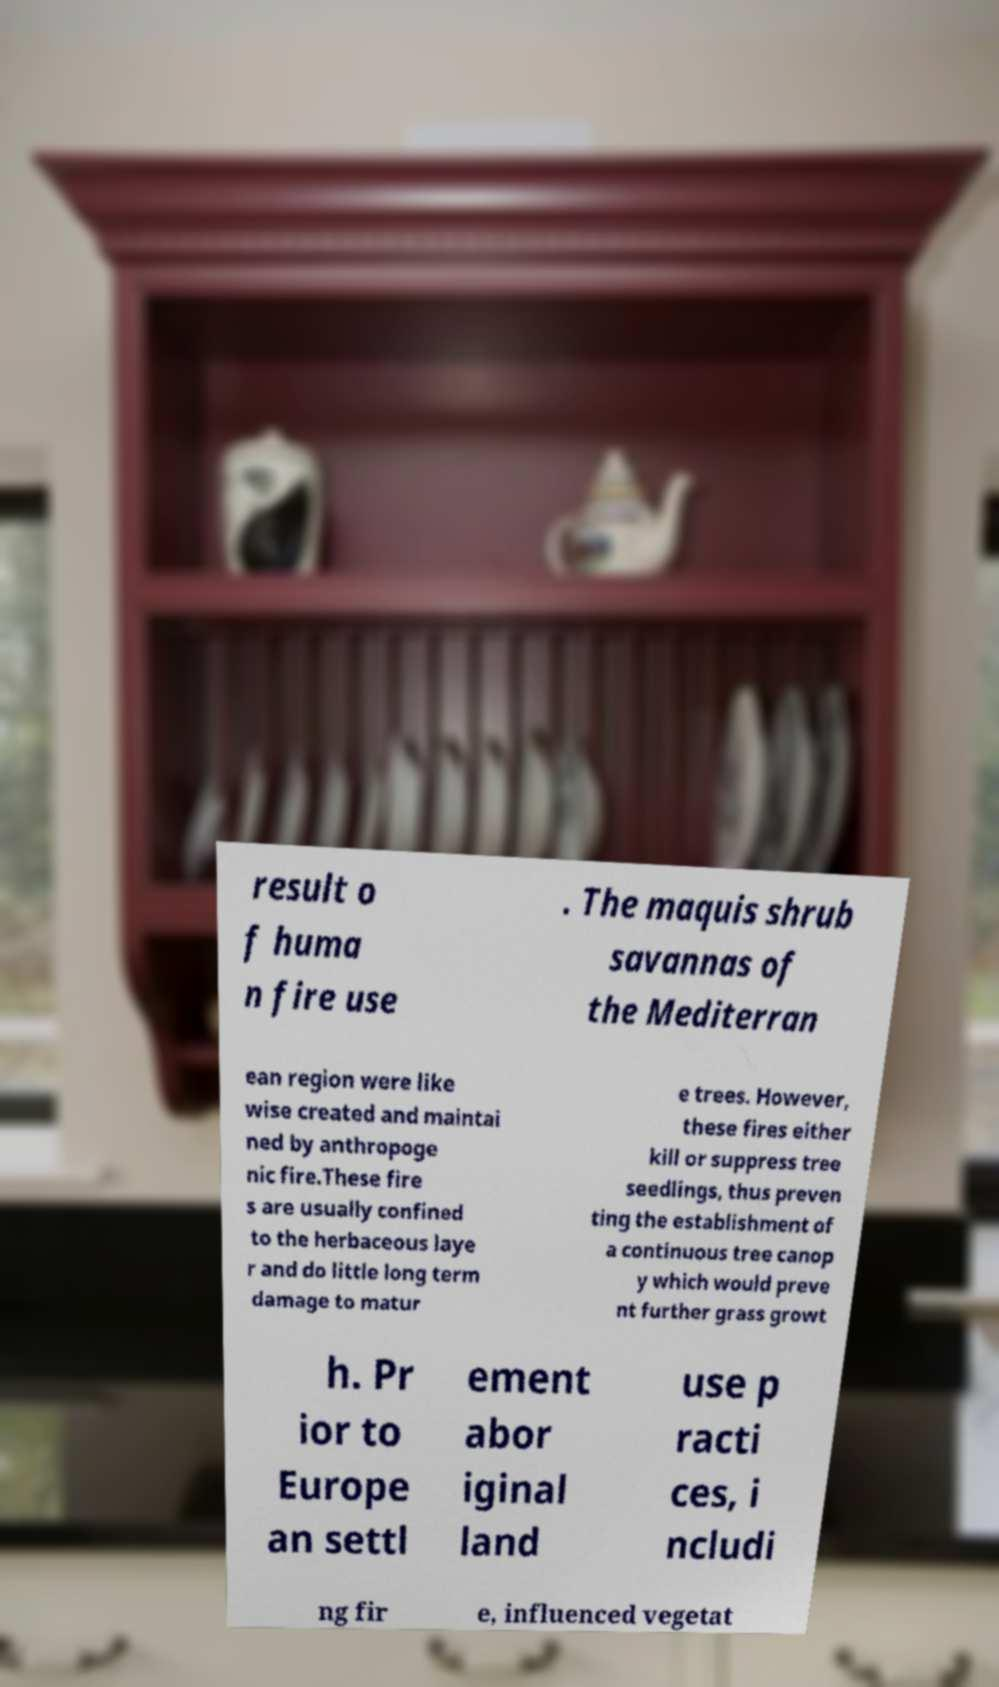For documentation purposes, I need the text within this image transcribed. Could you provide that? result o f huma n fire use . The maquis shrub savannas of the Mediterran ean region were like wise created and maintai ned by anthropoge nic fire.These fire s are usually confined to the herbaceous laye r and do little long term damage to matur e trees. However, these fires either kill or suppress tree seedlings, thus preven ting the establishment of a continuous tree canop y which would preve nt further grass growt h. Pr ior to Europe an settl ement abor iginal land use p racti ces, i ncludi ng fir e, influenced vegetat 